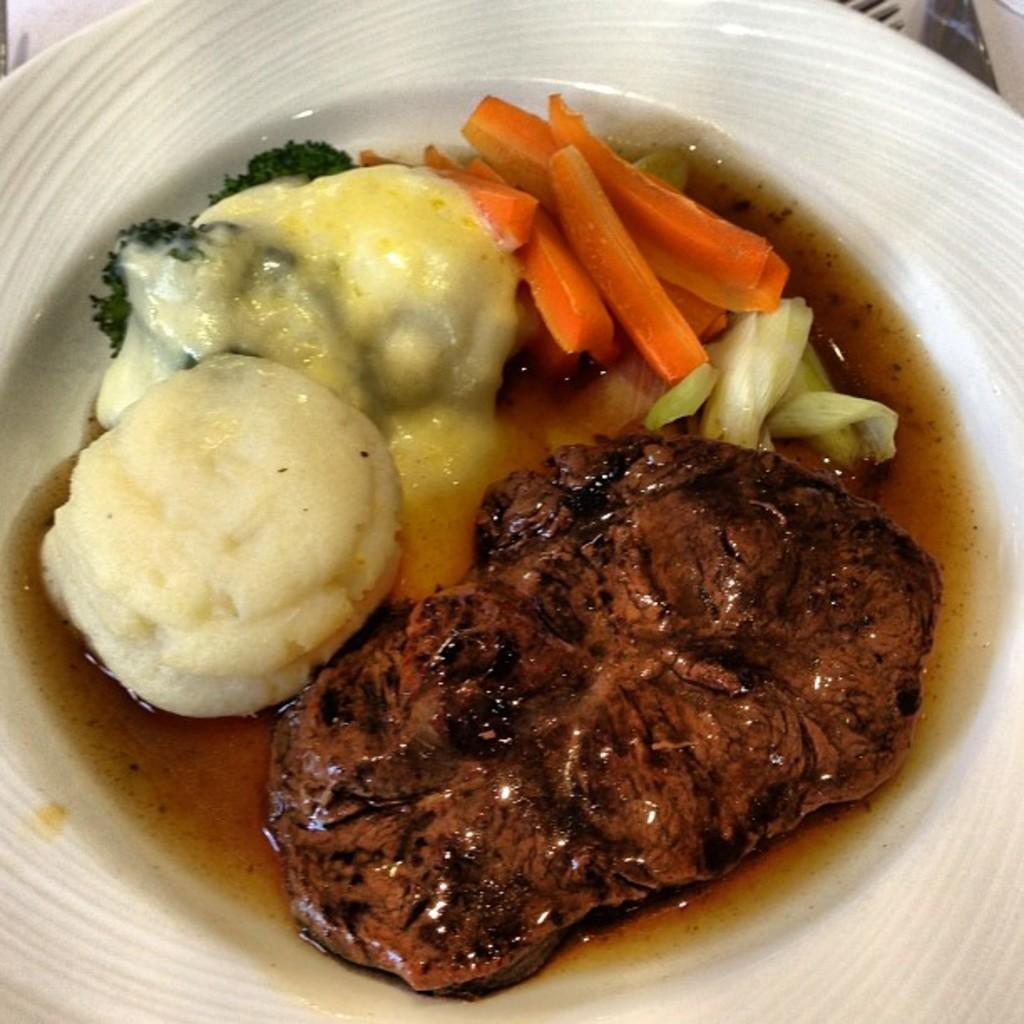What is the main subject of the image? The main subject of the image is food. What can be observed about the plate the food is on? The plate is white in color. How many different colors can be seen in the food? The food has various colors, including brown, white, cream, green, and orange. What type of bells can be heard ringing in the image? There are no bells present in the image, so no sound can be heard. Can you recite a verse that is written on the food in the image? There is no text or verse written on the food in the image. 